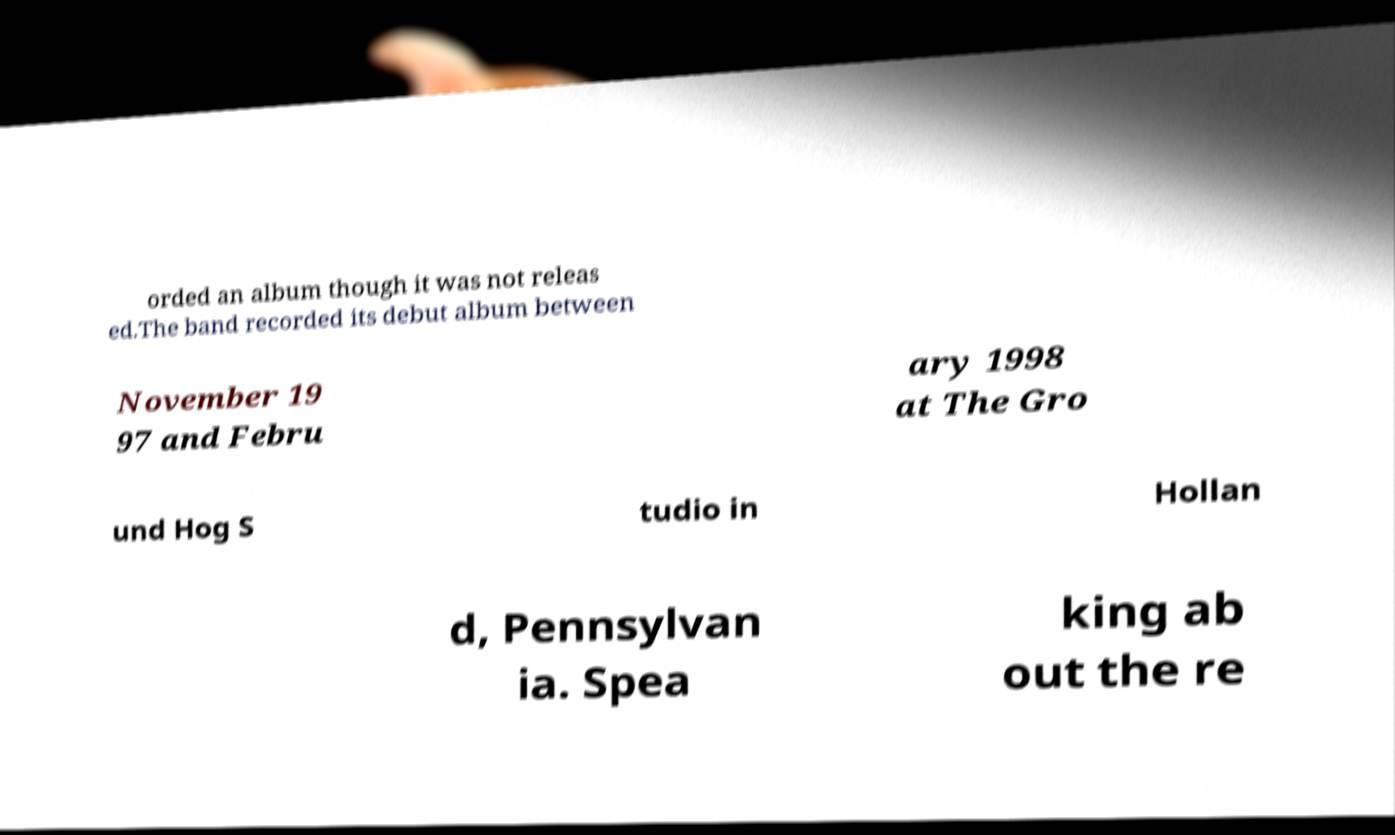There's text embedded in this image that I need extracted. Can you transcribe it verbatim? orded an album though it was not releas ed.The band recorded its debut album between November 19 97 and Febru ary 1998 at The Gro und Hog S tudio in Hollan d, Pennsylvan ia. Spea king ab out the re 